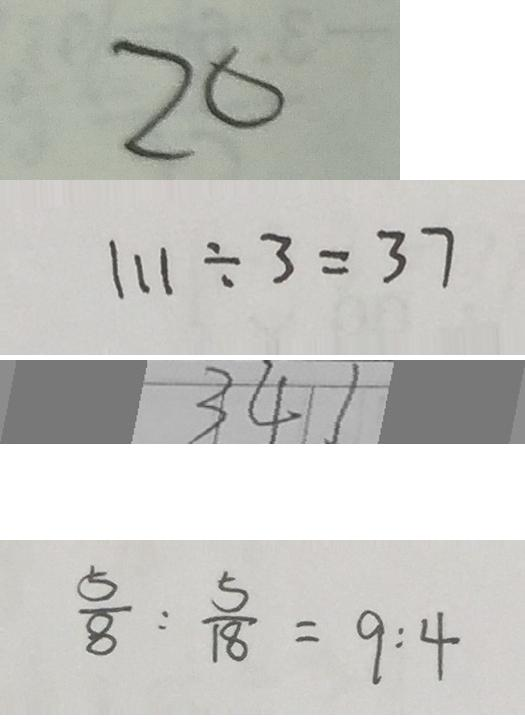Convert formula to latex. <formula><loc_0><loc_0><loc_500><loc_500>2 0 
 1 1 1 \div 3 = 3 7 
 3 4 1 
 \frac { 5 } { 8 } : \frac { 5 } { 1 8 } = 9 : 4</formula> 